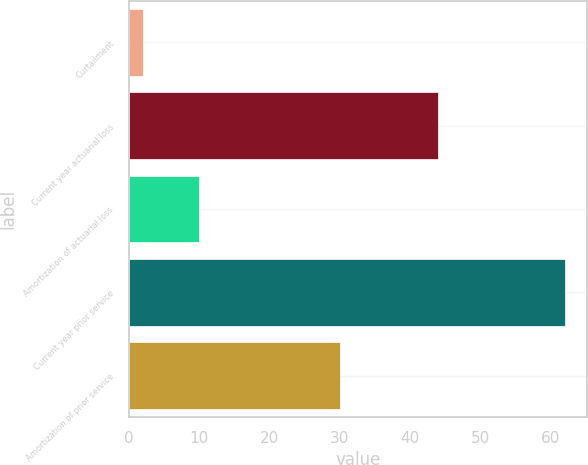Convert chart. <chart><loc_0><loc_0><loc_500><loc_500><bar_chart><fcel>Curtailment<fcel>Current year actuarial loss<fcel>Amortization of actuarial loss<fcel>Current year prior service<fcel>Amortization of prior service<nl><fcel>2<fcel>44<fcel>10<fcel>62<fcel>30<nl></chart> 